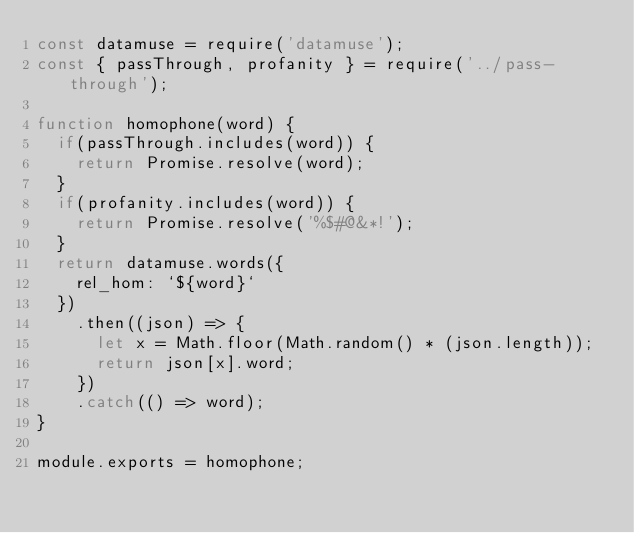Convert code to text. <code><loc_0><loc_0><loc_500><loc_500><_JavaScript_>const datamuse = require('datamuse');
const { passThrough, profanity } = require('../pass-through');

function homophone(word) {
  if(passThrough.includes(word)) {
    return Promise.resolve(word);
  }
  if(profanity.includes(word)) {
    return Promise.resolve('%$#@&*!');
  }
  return datamuse.words({
    rel_hom: `${word}`
  })
    .then((json) => {
      let x = Math.floor(Math.random() * (json.length));
      return json[x].word;
    })
    .catch(() => word);
}

module.exports = homophone;</code> 